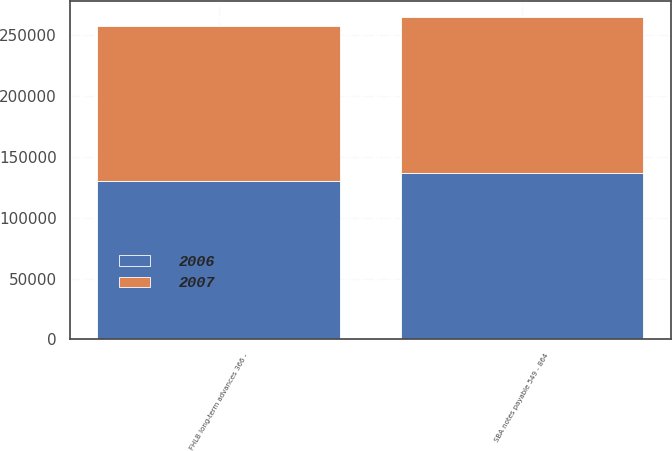Convert chart. <chart><loc_0><loc_0><loc_500><loc_500><stacked_bar_chart><ecel><fcel>FHLB long-term advances 366 -<fcel>SBA notes payable 549 - 864<nl><fcel>2007<fcel>127612<fcel>127612<nl><fcel>2006<fcel>130058<fcel>137058<nl></chart> 